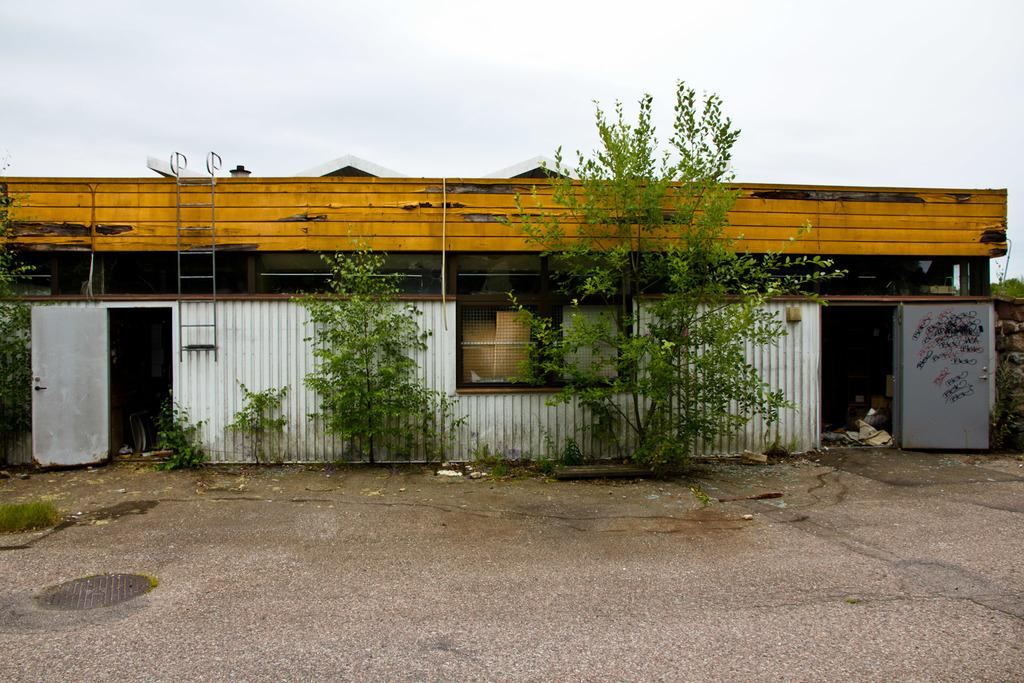What type of structure is visible in the image? There is a house in the image with a roof and windows. What can be found on the road in the image? There is a manhole on the road. What type of vegetation is present in the image? Plants and grass are visible in the image. What is hanging on the wall in the image? There is a ladder hanged on a wall. What is the condition of the sky in the image? The sky is visible and appears cloudy. What type of butter is being used to frame the plants in the image? There is no butter or framing of plants present in the image. 